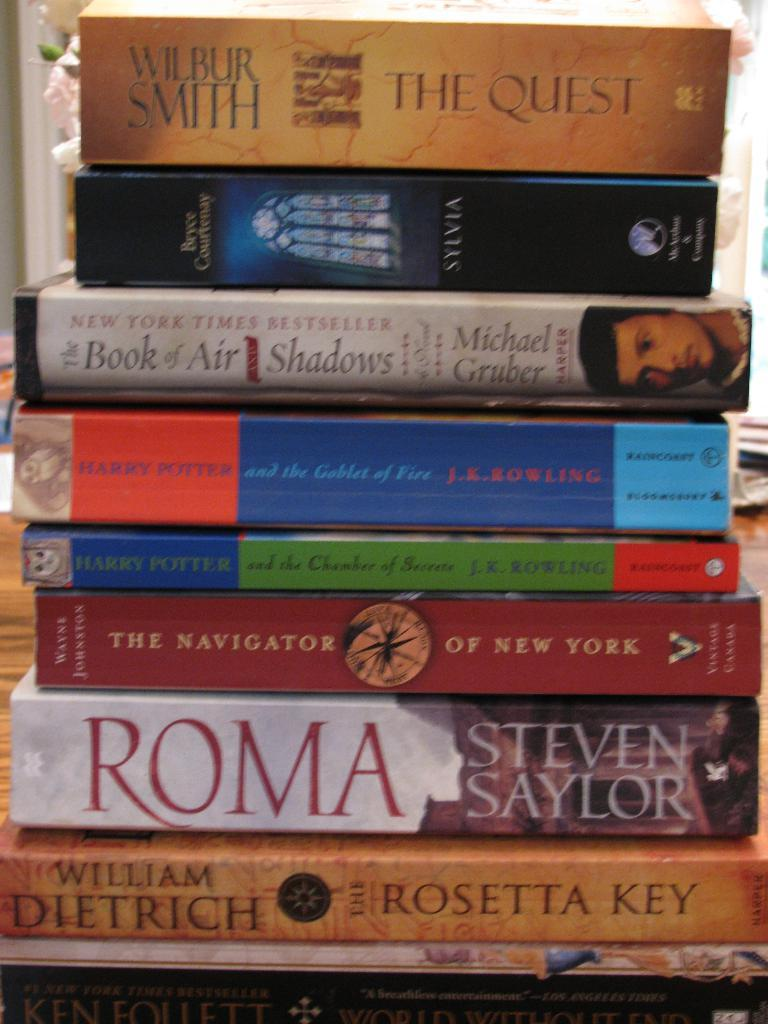What objects can be seen in the image? There are books in the image. What can be read or seen on the books? There is text visible in the image. Can you tell me what animals are present at the zoo in the image? There is no zoo or animals present in the image; it only features books with text. What type of sign can be seen in the image? There is no sign present in the image; it only features books with text. 